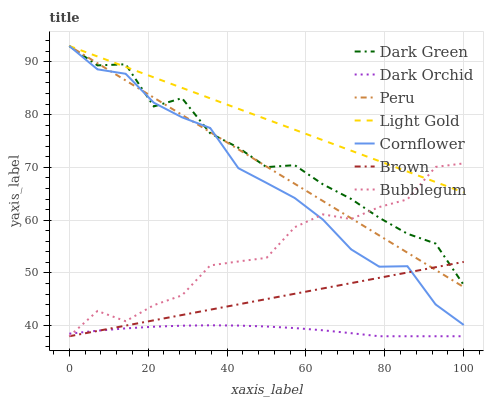Does Dark Orchid have the minimum area under the curve?
Answer yes or no. Yes. Does Light Gold have the maximum area under the curve?
Answer yes or no. Yes. Does Cornflower have the minimum area under the curve?
Answer yes or no. No. Does Cornflower have the maximum area under the curve?
Answer yes or no. No. Is Brown the smoothest?
Answer yes or no. Yes. Is Dark Green the roughest?
Answer yes or no. Yes. Is Cornflower the smoothest?
Answer yes or no. No. Is Cornflower the roughest?
Answer yes or no. No. Does Brown have the lowest value?
Answer yes or no. Yes. Does Cornflower have the lowest value?
Answer yes or no. No. Does Dark Green have the highest value?
Answer yes or no. Yes. Does Dark Orchid have the highest value?
Answer yes or no. No. Is Dark Orchid less than Light Gold?
Answer yes or no. Yes. Is Dark Green greater than Dark Orchid?
Answer yes or no. Yes. Does Bubblegum intersect Peru?
Answer yes or no. Yes. Is Bubblegum less than Peru?
Answer yes or no. No. Is Bubblegum greater than Peru?
Answer yes or no. No. Does Dark Orchid intersect Light Gold?
Answer yes or no. No. 